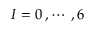Convert formula to latex. <formula><loc_0><loc_0><loc_500><loc_500>I = 0 \, , \cdots \, , 6</formula> 